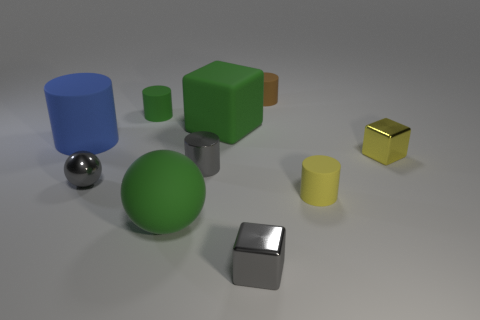Subtract all blue cylinders. How many cylinders are left? 4 Subtract 3 cylinders. How many cylinders are left? 2 Subtract all gray cylinders. How many cylinders are left? 4 Subtract all blue cylinders. Subtract all red balls. How many cylinders are left? 4 Subtract all balls. How many objects are left? 8 Subtract all green blocks. Subtract all metal balls. How many objects are left? 8 Add 7 tiny brown rubber things. How many tiny brown rubber things are left? 8 Add 7 big cylinders. How many big cylinders exist? 8 Subtract 0 blue blocks. How many objects are left? 10 